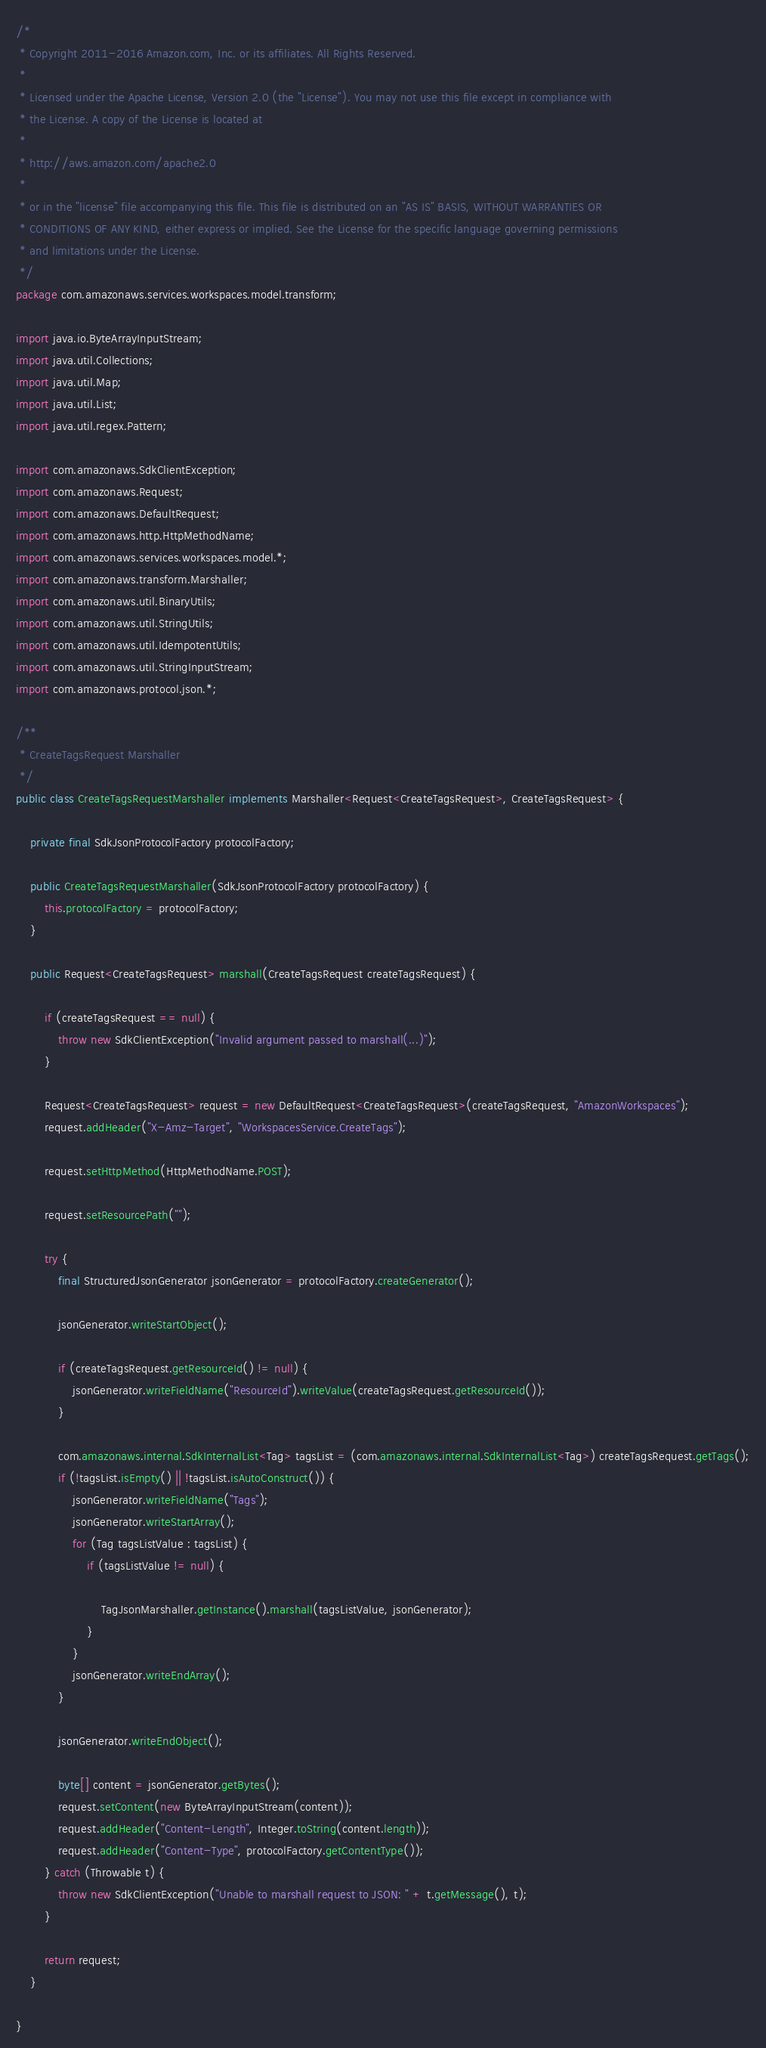<code> <loc_0><loc_0><loc_500><loc_500><_Java_>/*
 * Copyright 2011-2016 Amazon.com, Inc. or its affiliates. All Rights Reserved.
 * 
 * Licensed under the Apache License, Version 2.0 (the "License"). You may not use this file except in compliance with
 * the License. A copy of the License is located at
 * 
 * http://aws.amazon.com/apache2.0
 * 
 * or in the "license" file accompanying this file. This file is distributed on an "AS IS" BASIS, WITHOUT WARRANTIES OR
 * CONDITIONS OF ANY KIND, either express or implied. See the License for the specific language governing permissions
 * and limitations under the License.
 */
package com.amazonaws.services.workspaces.model.transform;

import java.io.ByteArrayInputStream;
import java.util.Collections;
import java.util.Map;
import java.util.List;
import java.util.regex.Pattern;

import com.amazonaws.SdkClientException;
import com.amazonaws.Request;
import com.amazonaws.DefaultRequest;
import com.amazonaws.http.HttpMethodName;
import com.amazonaws.services.workspaces.model.*;
import com.amazonaws.transform.Marshaller;
import com.amazonaws.util.BinaryUtils;
import com.amazonaws.util.StringUtils;
import com.amazonaws.util.IdempotentUtils;
import com.amazonaws.util.StringInputStream;
import com.amazonaws.protocol.json.*;

/**
 * CreateTagsRequest Marshaller
 */
public class CreateTagsRequestMarshaller implements Marshaller<Request<CreateTagsRequest>, CreateTagsRequest> {

    private final SdkJsonProtocolFactory protocolFactory;

    public CreateTagsRequestMarshaller(SdkJsonProtocolFactory protocolFactory) {
        this.protocolFactory = protocolFactory;
    }

    public Request<CreateTagsRequest> marshall(CreateTagsRequest createTagsRequest) {

        if (createTagsRequest == null) {
            throw new SdkClientException("Invalid argument passed to marshall(...)");
        }

        Request<CreateTagsRequest> request = new DefaultRequest<CreateTagsRequest>(createTagsRequest, "AmazonWorkspaces");
        request.addHeader("X-Amz-Target", "WorkspacesService.CreateTags");

        request.setHttpMethod(HttpMethodName.POST);

        request.setResourcePath("");

        try {
            final StructuredJsonGenerator jsonGenerator = protocolFactory.createGenerator();

            jsonGenerator.writeStartObject();

            if (createTagsRequest.getResourceId() != null) {
                jsonGenerator.writeFieldName("ResourceId").writeValue(createTagsRequest.getResourceId());
            }

            com.amazonaws.internal.SdkInternalList<Tag> tagsList = (com.amazonaws.internal.SdkInternalList<Tag>) createTagsRequest.getTags();
            if (!tagsList.isEmpty() || !tagsList.isAutoConstruct()) {
                jsonGenerator.writeFieldName("Tags");
                jsonGenerator.writeStartArray();
                for (Tag tagsListValue : tagsList) {
                    if (tagsListValue != null) {

                        TagJsonMarshaller.getInstance().marshall(tagsListValue, jsonGenerator);
                    }
                }
                jsonGenerator.writeEndArray();
            }

            jsonGenerator.writeEndObject();

            byte[] content = jsonGenerator.getBytes();
            request.setContent(new ByteArrayInputStream(content));
            request.addHeader("Content-Length", Integer.toString(content.length));
            request.addHeader("Content-Type", protocolFactory.getContentType());
        } catch (Throwable t) {
            throw new SdkClientException("Unable to marshall request to JSON: " + t.getMessage(), t);
        }

        return request;
    }

}
</code> 